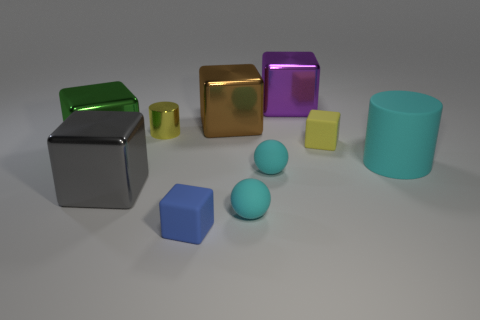Subtract all big purple blocks. How many blocks are left? 5 Subtract 1 cylinders. How many cylinders are left? 1 Subtract all brown cubes. How many yellow cylinders are left? 1 Subtract all gray cubes. How many cubes are left? 5 Subtract 0 yellow spheres. How many objects are left? 10 Subtract all blocks. How many objects are left? 4 Subtract all yellow balls. Subtract all yellow cylinders. How many balls are left? 2 Subtract all yellow matte objects. Subtract all small balls. How many objects are left? 7 Add 6 big cyan objects. How many big cyan objects are left? 7 Add 4 small shiny things. How many small shiny things exist? 5 